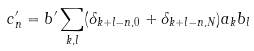Convert formula to latex. <formula><loc_0><loc_0><loc_500><loc_500>c ^ { \prime } _ { n } = b ^ { \prime } \sum _ { k , l } ( \delta _ { k + l - n , 0 } + \delta _ { k + l - n , N } ) a _ { k } b _ { l }</formula> 